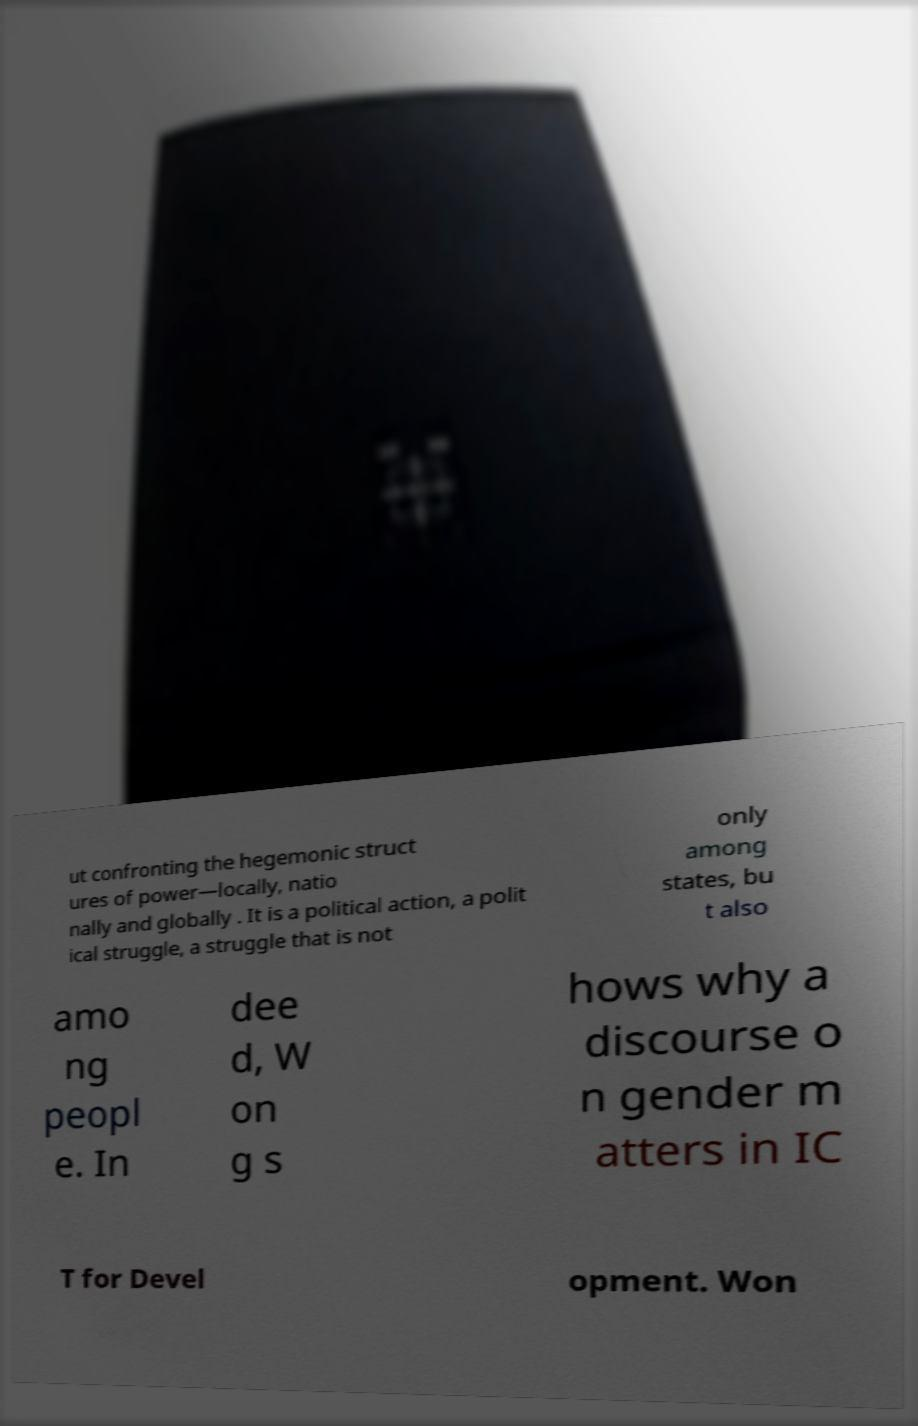Please identify and transcribe the text found in this image. ut confronting the hegemonic struct ures of power—locally, natio nally and globally . It is a political action, a polit ical struggle, a struggle that is not only among states, bu t also amo ng peopl e. In dee d, W on g s hows why a discourse o n gender m atters in IC T for Devel opment. Won 